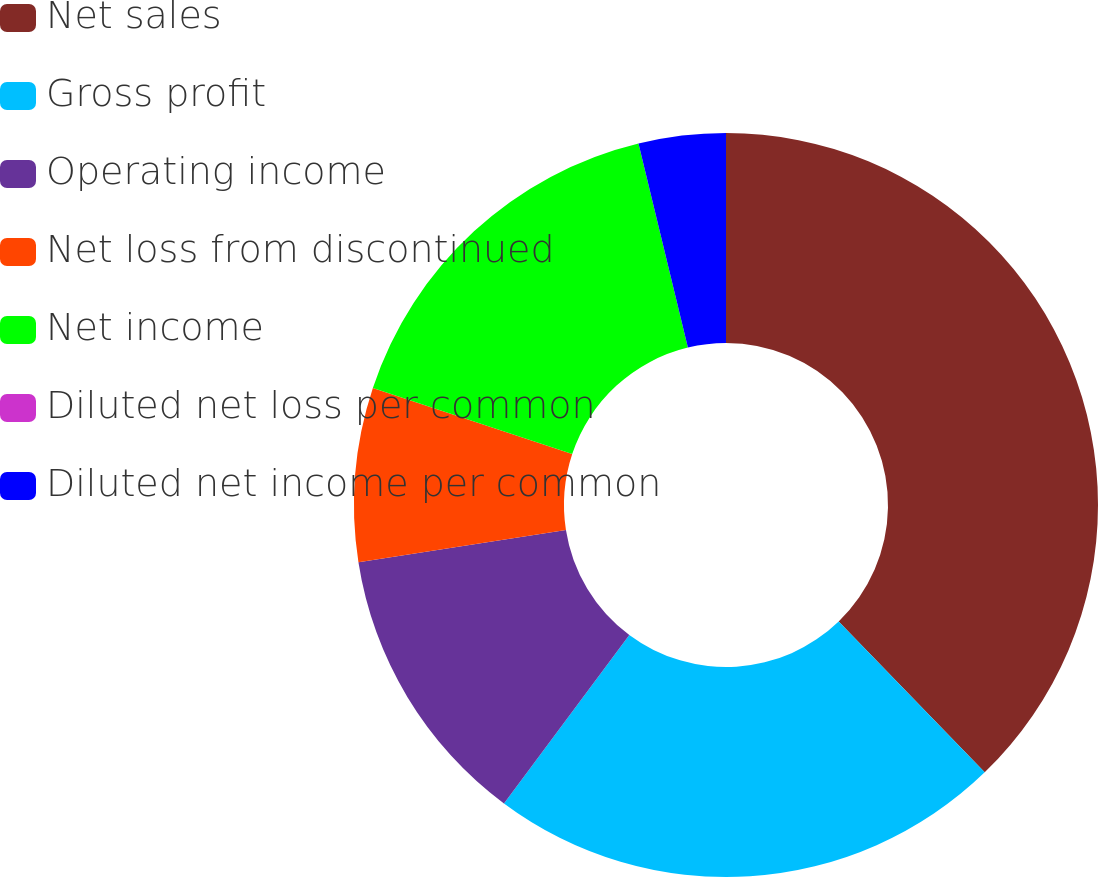<chart> <loc_0><loc_0><loc_500><loc_500><pie_chart><fcel>Net sales<fcel>Gross profit<fcel>Operating income<fcel>Net loss from discontinued<fcel>Net income<fcel>Diluted net loss per common<fcel>Diluted net income per common<nl><fcel>37.76%<fcel>22.42%<fcel>12.36%<fcel>7.55%<fcel>16.13%<fcel>0.0%<fcel>3.78%<nl></chart> 